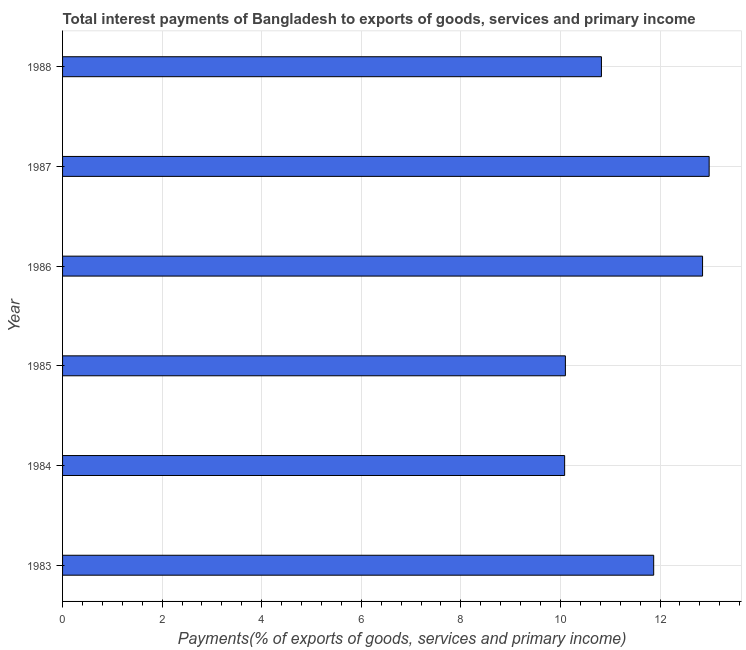Does the graph contain any zero values?
Keep it short and to the point. No. Does the graph contain grids?
Keep it short and to the point. Yes. What is the title of the graph?
Give a very brief answer. Total interest payments of Bangladesh to exports of goods, services and primary income. What is the label or title of the X-axis?
Provide a short and direct response. Payments(% of exports of goods, services and primary income). What is the total interest payments on external debt in 1986?
Your response must be concise. 12.85. Across all years, what is the maximum total interest payments on external debt?
Your answer should be very brief. 12.99. Across all years, what is the minimum total interest payments on external debt?
Provide a short and direct response. 10.08. In which year was the total interest payments on external debt maximum?
Offer a terse response. 1987. In which year was the total interest payments on external debt minimum?
Your answer should be very brief. 1984. What is the sum of the total interest payments on external debt?
Keep it short and to the point. 68.72. What is the difference between the total interest payments on external debt in 1985 and 1987?
Provide a succinct answer. -2.89. What is the average total interest payments on external debt per year?
Your answer should be compact. 11.45. What is the median total interest payments on external debt?
Offer a very short reply. 11.35. In how many years, is the total interest payments on external debt greater than 0.8 %?
Offer a terse response. 6. Do a majority of the years between 1985 and 1983 (inclusive) have total interest payments on external debt greater than 13.2 %?
Make the answer very short. Yes. What is the ratio of the total interest payments on external debt in 1983 to that in 1986?
Offer a very short reply. 0.92. Is the total interest payments on external debt in 1983 less than that in 1987?
Ensure brevity in your answer.  Yes. What is the difference between the highest and the second highest total interest payments on external debt?
Keep it short and to the point. 0.13. Is the sum of the total interest payments on external debt in 1984 and 1985 greater than the maximum total interest payments on external debt across all years?
Offer a very short reply. Yes. What is the difference between the highest and the lowest total interest payments on external debt?
Your answer should be compact. 2.9. Are all the bars in the graph horizontal?
Make the answer very short. Yes. How many years are there in the graph?
Your answer should be very brief. 6. What is the difference between two consecutive major ticks on the X-axis?
Make the answer very short. 2. Are the values on the major ticks of X-axis written in scientific E-notation?
Keep it short and to the point. No. What is the Payments(% of exports of goods, services and primary income) of 1983?
Ensure brevity in your answer.  11.87. What is the Payments(% of exports of goods, services and primary income) of 1984?
Give a very brief answer. 10.08. What is the Payments(% of exports of goods, services and primary income) in 1985?
Your response must be concise. 10.1. What is the Payments(% of exports of goods, services and primary income) of 1986?
Provide a succinct answer. 12.85. What is the Payments(% of exports of goods, services and primary income) in 1987?
Ensure brevity in your answer.  12.99. What is the Payments(% of exports of goods, services and primary income) in 1988?
Ensure brevity in your answer.  10.82. What is the difference between the Payments(% of exports of goods, services and primary income) in 1983 and 1984?
Ensure brevity in your answer.  1.79. What is the difference between the Payments(% of exports of goods, services and primary income) in 1983 and 1985?
Your answer should be compact. 1.77. What is the difference between the Payments(% of exports of goods, services and primary income) in 1983 and 1986?
Your response must be concise. -0.98. What is the difference between the Payments(% of exports of goods, services and primary income) in 1983 and 1987?
Keep it short and to the point. -1.11. What is the difference between the Payments(% of exports of goods, services and primary income) in 1983 and 1988?
Offer a very short reply. 1.05. What is the difference between the Payments(% of exports of goods, services and primary income) in 1984 and 1985?
Offer a very short reply. -0.02. What is the difference between the Payments(% of exports of goods, services and primary income) in 1984 and 1986?
Offer a terse response. -2.77. What is the difference between the Payments(% of exports of goods, services and primary income) in 1984 and 1987?
Offer a terse response. -2.9. What is the difference between the Payments(% of exports of goods, services and primary income) in 1984 and 1988?
Offer a terse response. -0.74. What is the difference between the Payments(% of exports of goods, services and primary income) in 1985 and 1986?
Your answer should be very brief. -2.76. What is the difference between the Payments(% of exports of goods, services and primary income) in 1985 and 1987?
Ensure brevity in your answer.  -2.89. What is the difference between the Payments(% of exports of goods, services and primary income) in 1985 and 1988?
Make the answer very short. -0.72. What is the difference between the Payments(% of exports of goods, services and primary income) in 1986 and 1987?
Keep it short and to the point. -0.13. What is the difference between the Payments(% of exports of goods, services and primary income) in 1986 and 1988?
Keep it short and to the point. 2.03. What is the difference between the Payments(% of exports of goods, services and primary income) in 1987 and 1988?
Ensure brevity in your answer.  2.16. What is the ratio of the Payments(% of exports of goods, services and primary income) in 1983 to that in 1984?
Your answer should be very brief. 1.18. What is the ratio of the Payments(% of exports of goods, services and primary income) in 1983 to that in 1985?
Your answer should be very brief. 1.18. What is the ratio of the Payments(% of exports of goods, services and primary income) in 1983 to that in 1986?
Provide a short and direct response. 0.92. What is the ratio of the Payments(% of exports of goods, services and primary income) in 1983 to that in 1987?
Keep it short and to the point. 0.91. What is the ratio of the Payments(% of exports of goods, services and primary income) in 1983 to that in 1988?
Your answer should be very brief. 1.1. What is the ratio of the Payments(% of exports of goods, services and primary income) in 1984 to that in 1986?
Make the answer very short. 0.78. What is the ratio of the Payments(% of exports of goods, services and primary income) in 1984 to that in 1987?
Your answer should be compact. 0.78. What is the ratio of the Payments(% of exports of goods, services and primary income) in 1984 to that in 1988?
Provide a short and direct response. 0.93. What is the ratio of the Payments(% of exports of goods, services and primary income) in 1985 to that in 1986?
Your answer should be very brief. 0.79. What is the ratio of the Payments(% of exports of goods, services and primary income) in 1985 to that in 1987?
Your response must be concise. 0.78. What is the ratio of the Payments(% of exports of goods, services and primary income) in 1985 to that in 1988?
Your response must be concise. 0.93. What is the ratio of the Payments(% of exports of goods, services and primary income) in 1986 to that in 1987?
Keep it short and to the point. 0.99. What is the ratio of the Payments(% of exports of goods, services and primary income) in 1986 to that in 1988?
Your response must be concise. 1.19. 